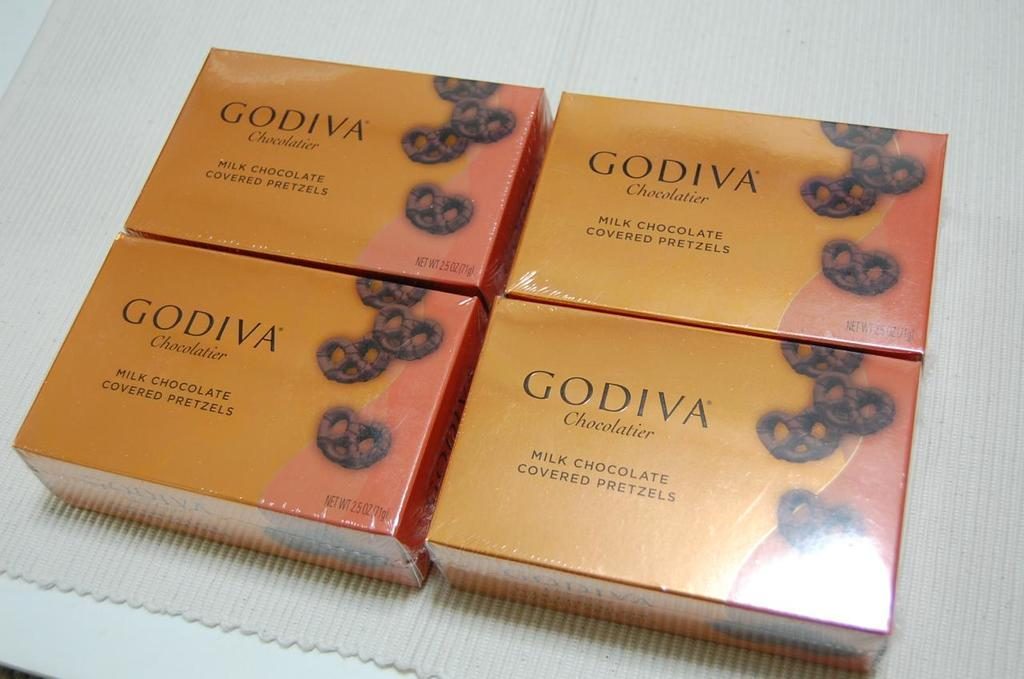<image>
Relay a brief, clear account of the picture shown. Four boxes of Godiva Milk Chocolate Covered Pretzels are displayed. 